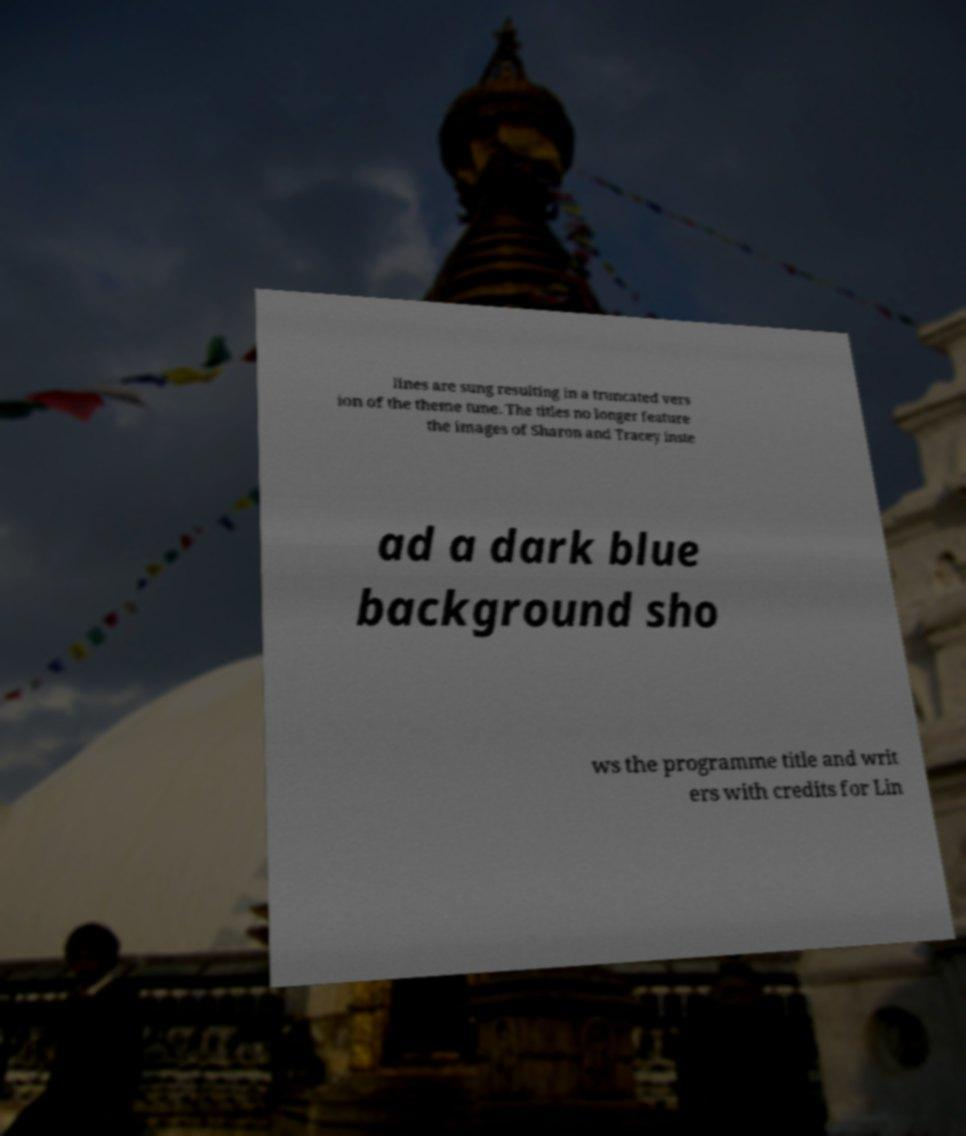There's text embedded in this image that I need extracted. Can you transcribe it verbatim? lines are sung resulting in a truncated vers ion of the theme tune. The titles no longer feature the images of Sharon and Tracey inste ad a dark blue background sho ws the programme title and writ ers with credits for Lin 